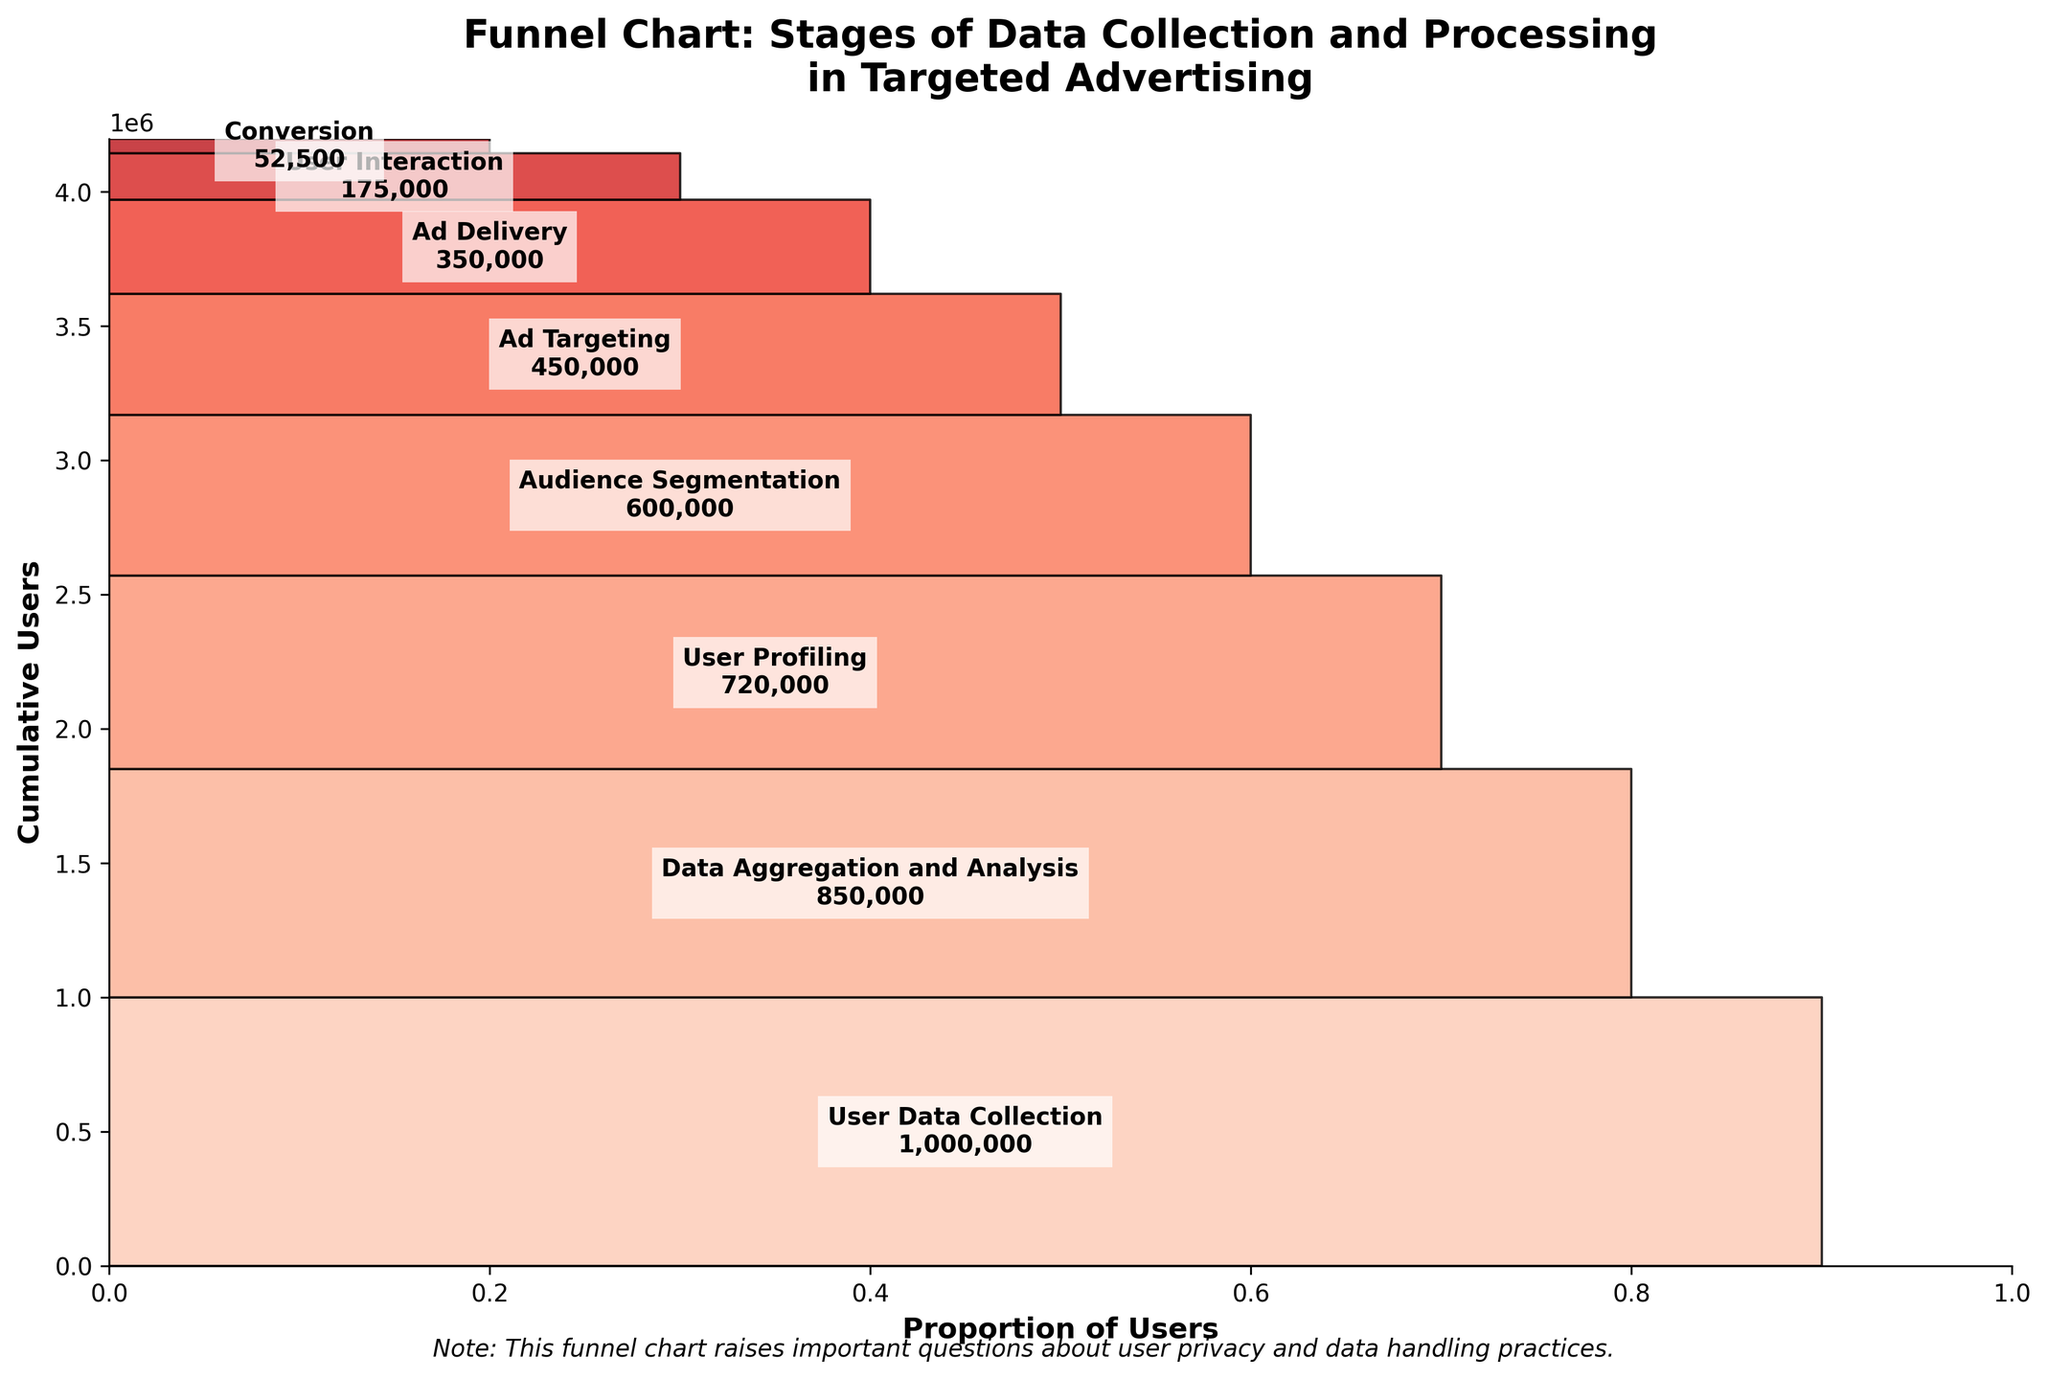What's the title of the funnel chart? To find the title of the funnel chart, look at the top of the chart where the main heading is usually placed. The title provides an overview of what the chart is about.
Answer: Funnel Chart: Stages of Data Collection and Processing in Targeted Advertising How many stages are depicted in the funnel chart? Count the distinct segments or stages labeled in the chart from the top to the bottom. Each label represents a stage in the process.
Answer: 8 What is the stage with the highest number of users? Observe the chart and look at the user count for each stage. The stage with the largest user count at the top of the funnel is the one with the highest number of users.
Answer: User Data Collection Which stage has half the number of users compared to the stage of Ad Delivery? Identify the stage of Ad Delivery and note its user count. Then find the stage which has close to half of that user count.
Answer: User Interaction What is the difference in user count between Data Aggregation and Analysis and Audience Segmentation? Identify and note the user counts for both Data Aggregation and Analysis and Audience Segmentation. Subtract the user count of Audience Segmentation from Data Aggregation and Analysis.
Answer: 250,000 In which stage does the funnel see the biggest drop in the number of users? Compare the user counts between consecutive stages and identify the pair of stages with the highest difference in user counts.
Answer: User Profiling to Audience Segmentation How does the user count at the Conversion stage compare to the User Interaction stage? Look at the user counts for both the Conversion and User Interaction stages. Determine the difference between these counts.
Answer: User Interaction has 122,500 more users than Conversion What happens to the user counts as we move down the funnel stages? Observe the trend in the user counts from the top stage to the bottom stage. The user count decreases progressively as we move down the funnel.
Answer: The user counts decrease What might the note at the bottom of the chart indicate in terms of privacy? Read the note. It indicates that the funnel chart raises questions about how user data is handled and suggests concerns about privacy practices.
Answer: Privacy concerns How many users are there cumulatively by the time of Audience Segmentation? Add the user counts progressively up to the Audience Segmentation stage to get the cumulative count.
Answer: 3,170,000 